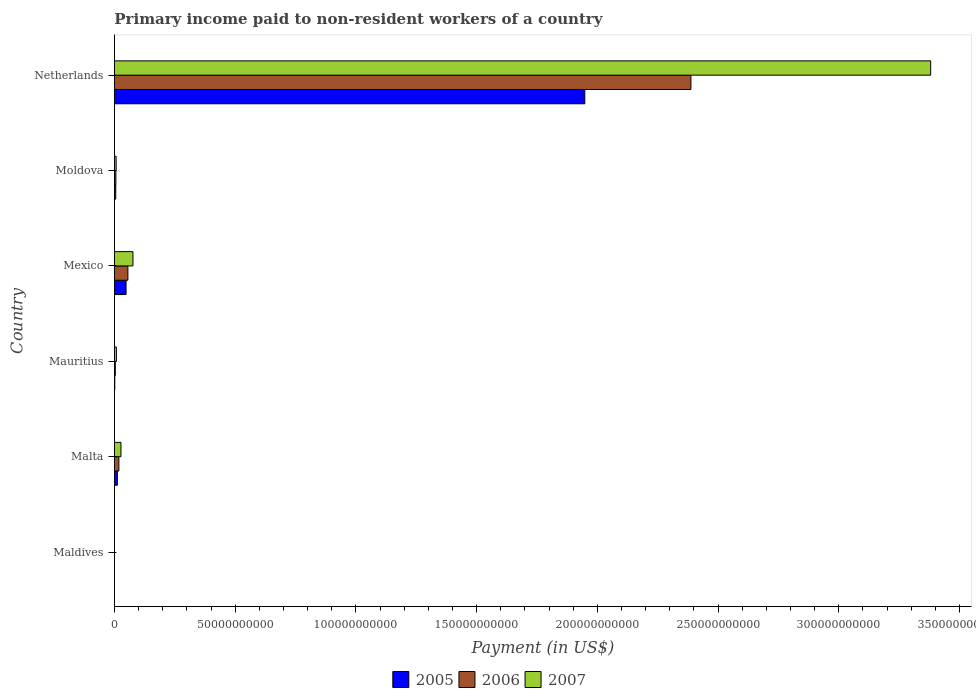How many different coloured bars are there?
Your answer should be compact. 3. How many groups of bars are there?
Keep it short and to the point. 6. Are the number of bars per tick equal to the number of legend labels?
Your answer should be very brief. Yes. Are the number of bars on each tick of the Y-axis equal?
Keep it short and to the point. Yes. What is the amount paid to workers in 2005 in Mauritius?
Provide a short and direct response. 1.43e+08. Across all countries, what is the maximum amount paid to workers in 2007?
Make the answer very short. 3.38e+11. Across all countries, what is the minimum amount paid to workers in 2005?
Make the answer very short. 1.09e+07. In which country was the amount paid to workers in 2005 minimum?
Provide a short and direct response. Maldives. What is the total amount paid to workers in 2006 in the graph?
Keep it short and to the point. 2.47e+11. What is the difference between the amount paid to workers in 2007 in Mauritius and that in Netherlands?
Your response must be concise. -3.37e+11. What is the difference between the amount paid to workers in 2006 in Moldova and the amount paid to workers in 2005 in Mauritius?
Offer a very short reply. 4.63e+08. What is the average amount paid to workers in 2007 per country?
Keep it short and to the point. 5.83e+1. What is the difference between the amount paid to workers in 2005 and amount paid to workers in 2006 in Mauritius?
Provide a succinct answer. -2.31e+08. In how many countries, is the amount paid to workers in 2005 greater than 80000000000 US$?
Make the answer very short. 1. What is the ratio of the amount paid to workers in 2007 in Moldova to that in Netherlands?
Make the answer very short. 0. Is the amount paid to workers in 2006 in Malta less than that in Mauritius?
Make the answer very short. No. Is the difference between the amount paid to workers in 2005 in Maldives and Netherlands greater than the difference between the amount paid to workers in 2006 in Maldives and Netherlands?
Make the answer very short. Yes. What is the difference between the highest and the second highest amount paid to workers in 2006?
Your answer should be very brief. 2.33e+11. What is the difference between the highest and the lowest amount paid to workers in 2006?
Provide a short and direct response. 2.39e+11. In how many countries, is the amount paid to workers in 2005 greater than the average amount paid to workers in 2005 taken over all countries?
Provide a succinct answer. 1. Is the sum of the amount paid to workers in 2007 in Malta and Mauritius greater than the maximum amount paid to workers in 2005 across all countries?
Your response must be concise. No. What does the 2nd bar from the bottom in Mauritius represents?
Provide a short and direct response. 2006. Is it the case that in every country, the sum of the amount paid to workers in 2006 and amount paid to workers in 2005 is greater than the amount paid to workers in 2007?
Ensure brevity in your answer.  No. Are all the bars in the graph horizontal?
Your response must be concise. Yes. Are the values on the major ticks of X-axis written in scientific E-notation?
Your answer should be very brief. No. Does the graph contain any zero values?
Give a very brief answer. No. Does the graph contain grids?
Provide a succinct answer. No. Where does the legend appear in the graph?
Keep it short and to the point. Bottom center. How are the legend labels stacked?
Ensure brevity in your answer.  Horizontal. What is the title of the graph?
Ensure brevity in your answer.  Primary income paid to non-resident workers of a country. What is the label or title of the X-axis?
Ensure brevity in your answer.  Payment (in US$). What is the Payment (in US$) of 2005 in Maldives?
Offer a very short reply. 1.09e+07. What is the Payment (in US$) in 2006 in Maldives?
Provide a succinct answer. 1.56e+07. What is the Payment (in US$) of 2007 in Maldives?
Your response must be concise. 2.67e+07. What is the Payment (in US$) of 2005 in Malta?
Offer a very short reply. 1.21e+09. What is the Payment (in US$) in 2006 in Malta?
Keep it short and to the point. 1.84e+09. What is the Payment (in US$) of 2007 in Malta?
Keep it short and to the point. 2.71e+09. What is the Payment (in US$) of 2005 in Mauritius?
Your answer should be very brief. 1.43e+08. What is the Payment (in US$) of 2006 in Mauritius?
Provide a short and direct response. 3.74e+08. What is the Payment (in US$) in 2007 in Mauritius?
Offer a terse response. 8.16e+08. What is the Payment (in US$) of 2005 in Mexico?
Give a very brief answer. 4.82e+09. What is the Payment (in US$) of 2006 in Mexico?
Offer a terse response. 5.58e+09. What is the Payment (in US$) of 2007 in Mexico?
Your answer should be compact. 7.66e+09. What is the Payment (in US$) of 2005 in Moldova?
Offer a terse response. 5.39e+08. What is the Payment (in US$) of 2006 in Moldova?
Offer a very short reply. 6.06e+08. What is the Payment (in US$) of 2007 in Moldova?
Offer a very short reply. 7.10e+08. What is the Payment (in US$) of 2005 in Netherlands?
Your answer should be very brief. 1.95e+11. What is the Payment (in US$) in 2006 in Netherlands?
Provide a succinct answer. 2.39e+11. What is the Payment (in US$) of 2007 in Netherlands?
Provide a short and direct response. 3.38e+11. Across all countries, what is the maximum Payment (in US$) in 2005?
Provide a short and direct response. 1.95e+11. Across all countries, what is the maximum Payment (in US$) in 2006?
Offer a very short reply. 2.39e+11. Across all countries, what is the maximum Payment (in US$) of 2007?
Keep it short and to the point. 3.38e+11. Across all countries, what is the minimum Payment (in US$) in 2005?
Offer a very short reply. 1.09e+07. Across all countries, what is the minimum Payment (in US$) of 2006?
Make the answer very short. 1.56e+07. Across all countries, what is the minimum Payment (in US$) of 2007?
Offer a terse response. 2.67e+07. What is the total Payment (in US$) in 2005 in the graph?
Provide a short and direct response. 2.02e+11. What is the total Payment (in US$) of 2006 in the graph?
Give a very brief answer. 2.47e+11. What is the total Payment (in US$) of 2007 in the graph?
Give a very brief answer. 3.50e+11. What is the difference between the Payment (in US$) of 2005 in Maldives and that in Malta?
Give a very brief answer. -1.20e+09. What is the difference between the Payment (in US$) in 2006 in Maldives and that in Malta?
Keep it short and to the point. -1.82e+09. What is the difference between the Payment (in US$) in 2007 in Maldives and that in Malta?
Ensure brevity in your answer.  -2.68e+09. What is the difference between the Payment (in US$) of 2005 in Maldives and that in Mauritius?
Ensure brevity in your answer.  -1.32e+08. What is the difference between the Payment (in US$) in 2006 in Maldives and that in Mauritius?
Make the answer very short. -3.58e+08. What is the difference between the Payment (in US$) of 2007 in Maldives and that in Mauritius?
Give a very brief answer. -7.90e+08. What is the difference between the Payment (in US$) of 2005 in Maldives and that in Mexico?
Provide a short and direct response. -4.81e+09. What is the difference between the Payment (in US$) in 2006 in Maldives and that in Mexico?
Your answer should be compact. -5.56e+09. What is the difference between the Payment (in US$) of 2007 in Maldives and that in Mexico?
Provide a succinct answer. -7.64e+09. What is the difference between the Payment (in US$) in 2005 in Maldives and that in Moldova?
Offer a terse response. -5.28e+08. What is the difference between the Payment (in US$) of 2006 in Maldives and that in Moldova?
Ensure brevity in your answer.  -5.90e+08. What is the difference between the Payment (in US$) in 2007 in Maldives and that in Moldova?
Ensure brevity in your answer.  -6.83e+08. What is the difference between the Payment (in US$) of 2005 in Maldives and that in Netherlands?
Give a very brief answer. -1.95e+11. What is the difference between the Payment (in US$) in 2006 in Maldives and that in Netherlands?
Your answer should be very brief. -2.39e+11. What is the difference between the Payment (in US$) in 2007 in Maldives and that in Netherlands?
Your answer should be very brief. -3.38e+11. What is the difference between the Payment (in US$) in 2005 in Malta and that in Mauritius?
Provide a succinct answer. 1.06e+09. What is the difference between the Payment (in US$) in 2006 in Malta and that in Mauritius?
Offer a very short reply. 1.47e+09. What is the difference between the Payment (in US$) in 2007 in Malta and that in Mauritius?
Your answer should be very brief. 1.89e+09. What is the difference between the Payment (in US$) in 2005 in Malta and that in Mexico?
Your response must be concise. -3.61e+09. What is the difference between the Payment (in US$) in 2006 in Malta and that in Mexico?
Make the answer very short. -3.74e+09. What is the difference between the Payment (in US$) of 2007 in Malta and that in Mexico?
Offer a very short reply. -4.95e+09. What is the difference between the Payment (in US$) of 2005 in Malta and that in Moldova?
Ensure brevity in your answer.  6.69e+08. What is the difference between the Payment (in US$) in 2006 in Malta and that in Moldova?
Make the answer very short. 1.23e+09. What is the difference between the Payment (in US$) in 2007 in Malta and that in Moldova?
Your answer should be very brief. 2.00e+09. What is the difference between the Payment (in US$) of 2005 in Malta and that in Netherlands?
Give a very brief answer. -1.94e+11. What is the difference between the Payment (in US$) of 2006 in Malta and that in Netherlands?
Your answer should be compact. -2.37e+11. What is the difference between the Payment (in US$) of 2007 in Malta and that in Netherlands?
Your response must be concise. -3.35e+11. What is the difference between the Payment (in US$) in 2005 in Mauritius and that in Mexico?
Provide a short and direct response. -4.68e+09. What is the difference between the Payment (in US$) in 2006 in Mauritius and that in Mexico?
Provide a succinct answer. -5.20e+09. What is the difference between the Payment (in US$) in 2007 in Mauritius and that in Mexico?
Make the answer very short. -6.85e+09. What is the difference between the Payment (in US$) of 2005 in Mauritius and that in Moldova?
Keep it short and to the point. -3.96e+08. What is the difference between the Payment (in US$) of 2006 in Mauritius and that in Moldova?
Offer a very short reply. -2.32e+08. What is the difference between the Payment (in US$) of 2007 in Mauritius and that in Moldova?
Offer a terse response. 1.06e+08. What is the difference between the Payment (in US$) of 2005 in Mauritius and that in Netherlands?
Offer a terse response. -1.95e+11. What is the difference between the Payment (in US$) in 2006 in Mauritius and that in Netherlands?
Offer a terse response. -2.38e+11. What is the difference between the Payment (in US$) in 2007 in Mauritius and that in Netherlands?
Give a very brief answer. -3.37e+11. What is the difference between the Payment (in US$) in 2005 in Mexico and that in Moldova?
Your answer should be compact. 4.28e+09. What is the difference between the Payment (in US$) in 2006 in Mexico and that in Moldova?
Make the answer very short. 4.97e+09. What is the difference between the Payment (in US$) of 2007 in Mexico and that in Moldova?
Make the answer very short. 6.95e+09. What is the difference between the Payment (in US$) in 2005 in Mexico and that in Netherlands?
Offer a terse response. -1.90e+11. What is the difference between the Payment (in US$) in 2006 in Mexico and that in Netherlands?
Offer a very short reply. -2.33e+11. What is the difference between the Payment (in US$) in 2007 in Mexico and that in Netherlands?
Your answer should be very brief. -3.30e+11. What is the difference between the Payment (in US$) of 2005 in Moldova and that in Netherlands?
Offer a terse response. -1.94e+11. What is the difference between the Payment (in US$) in 2006 in Moldova and that in Netherlands?
Keep it short and to the point. -2.38e+11. What is the difference between the Payment (in US$) in 2007 in Moldova and that in Netherlands?
Your response must be concise. -3.37e+11. What is the difference between the Payment (in US$) of 2005 in Maldives and the Payment (in US$) of 2006 in Malta?
Offer a terse response. -1.83e+09. What is the difference between the Payment (in US$) in 2005 in Maldives and the Payment (in US$) in 2007 in Malta?
Make the answer very short. -2.70e+09. What is the difference between the Payment (in US$) in 2006 in Maldives and the Payment (in US$) in 2007 in Malta?
Give a very brief answer. -2.70e+09. What is the difference between the Payment (in US$) of 2005 in Maldives and the Payment (in US$) of 2006 in Mauritius?
Provide a succinct answer. -3.63e+08. What is the difference between the Payment (in US$) of 2005 in Maldives and the Payment (in US$) of 2007 in Mauritius?
Provide a short and direct response. -8.05e+08. What is the difference between the Payment (in US$) in 2006 in Maldives and the Payment (in US$) in 2007 in Mauritius?
Make the answer very short. -8.01e+08. What is the difference between the Payment (in US$) of 2005 in Maldives and the Payment (in US$) of 2006 in Mexico?
Provide a short and direct response. -5.57e+09. What is the difference between the Payment (in US$) in 2005 in Maldives and the Payment (in US$) in 2007 in Mexico?
Provide a short and direct response. -7.65e+09. What is the difference between the Payment (in US$) in 2006 in Maldives and the Payment (in US$) in 2007 in Mexico?
Your answer should be very brief. -7.65e+09. What is the difference between the Payment (in US$) of 2005 in Maldives and the Payment (in US$) of 2006 in Moldova?
Your answer should be compact. -5.95e+08. What is the difference between the Payment (in US$) in 2005 in Maldives and the Payment (in US$) in 2007 in Moldova?
Make the answer very short. -6.99e+08. What is the difference between the Payment (in US$) of 2006 in Maldives and the Payment (in US$) of 2007 in Moldova?
Provide a succinct answer. -6.95e+08. What is the difference between the Payment (in US$) in 2005 in Maldives and the Payment (in US$) in 2006 in Netherlands?
Give a very brief answer. -2.39e+11. What is the difference between the Payment (in US$) in 2005 in Maldives and the Payment (in US$) in 2007 in Netherlands?
Provide a succinct answer. -3.38e+11. What is the difference between the Payment (in US$) in 2006 in Maldives and the Payment (in US$) in 2007 in Netherlands?
Provide a succinct answer. -3.38e+11. What is the difference between the Payment (in US$) of 2005 in Malta and the Payment (in US$) of 2006 in Mauritius?
Offer a terse response. 8.34e+08. What is the difference between the Payment (in US$) of 2005 in Malta and the Payment (in US$) of 2007 in Mauritius?
Provide a short and direct response. 3.91e+08. What is the difference between the Payment (in US$) in 2006 in Malta and the Payment (in US$) in 2007 in Mauritius?
Your answer should be very brief. 1.02e+09. What is the difference between the Payment (in US$) of 2005 in Malta and the Payment (in US$) of 2006 in Mexico?
Your answer should be compact. -4.37e+09. What is the difference between the Payment (in US$) in 2005 in Malta and the Payment (in US$) in 2007 in Mexico?
Offer a terse response. -6.46e+09. What is the difference between the Payment (in US$) in 2006 in Malta and the Payment (in US$) in 2007 in Mexico?
Offer a very short reply. -5.82e+09. What is the difference between the Payment (in US$) of 2005 in Malta and the Payment (in US$) of 2006 in Moldova?
Make the answer very short. 6.02e+08. What is the difference between the Payment (in US$) of 2005 in Malta and the Payment (in US$) of 2007 in Moldova?
Keep it short and to the point. 4.98e+08. What is the difference between the Payment (in US$) in 2006 in Malta and the Payment (in US$) in 2007 in Moldova?
Provide a short and direct response. 1.13e+09. What is the difference between the Payment (in US$) in 2005 in Malta and the Payment (in US$) in 2006 in Netherlands?
Give a very brief answer. -2.38e+11. What is the difference between the Payment (in US$) in 2005 in Malta and the Payment (in US$) in 2007 in Netherlands?
Keep it short and to the point. -3.37e+11. What is the difference between the Payment (in US$) of 2006 in Malta and the Payment (in US$) of 2007 in Netherlands?
Your answer should be very brief. -3.36e+11. What is the difference between the Payment (in US$) of 2005 in Mauritius and the Payment (in US$) of 2006 in Mexico?
Offer a terse response. -5.44e+09. What is the difference between the Payment (in US$) in 2005 in Mauritius and the Payment (in US$) in 2007 in Mexico?
Give a very brief answer. -7.52e+09. What is the difference between the Payment (in US$) in 2006 in Mauritius and the Payment (in US$) in 2007 in Mexico?
Your response must be concise. -7.29e+09. What is the difference between the Payment (in US$) in 2005 in Mauritius and the Payment (in US$) in 2006 in Moldova?
Your answer should be compact. -4.63e+08. What is the difference between the Payment (in US$) of 2005 in Mauritius and the Payment (in US$) of 2007 in Moldova?
Provide a succinct answer. -5.67e+08. What is the difference between the Payment (in US$) of 2006 in Mauritius and the Payment (in US$) of 2007 in Moldova?
Offer a very short reply. -3.36e+08. What is the difference between the Payment (in US$) of 2005 in Mauritius and the Payment (in US$) of 2006 in Netherlands?
Your answer should be very brief. -2.39e+11. What is the difference between the Payment (in US$) of 2005 in Mauritius and the Payment (in US$) of 2007 in Netherlands?
Your response must be concise. -3.38e+11. What is the difference between the Payment (in US$) in 2006 in Mauritius and the Payment (in US$) in 2007 in Netherlands?
Make the answer very short. -3.38e+11. What is the difference between the Payment (in US$) of 2005 in Mexico and the Payment (in US$) of 2006 in Moldova?
Make the answer very short. 4.21e+09. What is the difference between the Payment (in US$) of 2005 in Mexico and the Payment (in US$) of 2007 in Moldova?
Your answer should be compact. 4.11e+09. What is the difference between the Payment (in US$) in 2006 in Mexico and the Payment (in US$) in 2007 in Moldova?
Ensure brevity in your answer.  4.87e+09. What is the difference between the Payment (in US$) of 2005 in Mexico and the Payment (in US$) of 2006 in Netherlands?
Provide a succinct answer. -2.34e+11. What is the difference between the Payment (in US$) in 2005 in Mexico and the Payment (in US$) in 2007 in Netherlands?
Provide a short and direct response. -3.33e+11. What is the difference between the Payment (in US$) in 2006 in Mexico and the Payment (in US$) in 2007 in Netherlands?
Make the answer very short. -3.32e+11. What is the difference between the Payment (in US$) in 2005 in Moldova and the Payment (in US$) in 2006 in Netherlands?
Ensure brevity in your answer.  -2.38e+11. What is the difference between the Payment (in US$) of 2005 in Moldova and the Payment (in US$) of 2007 in Netherlands?
Your response must be concise. -3.37e+11. What is the difference between the Payment (in US$) in 2006 in Moldova and the Payment (in US$) in 2007 in Netherlands?
Provide a succinct answer. -3.37e+11. What is the average Payment (in US$) of 2005 per country?
Your response must be concise. 3.36e+1. What is the average Payment (in US$) of 2006 per country?
Ensure brevity in your answer.  4.12e+1. What is the average Payment (in US$) of 2007 per country?
Offer a very short reply. 5.83e+1. What is the difference between the Payment (in US$) in 2005 and Payment (in US$) in 2006 in Maldives?
Keep it short and to the point. -4.70e+06. What is the difference between the Payment (in US$) in 2005 and Payment (in US$) in 2007 in Maldives?
Keep it short and to the point. -1.58e+07. What is the difference between the Payment (in US$) in 2006 and Payment (in US$) in 2007 in Maldives?
Your response must be concise. -1.11e+07. What is the difference between the Payment (in US$) of 2005 and Payment (in US$) of 2006 in Malta?
Provide a short and direct response. -6.32e+08. What is the difference between the Payment (in US$) of 2005 and Payment (in US$) of 2007 in Malta?
Give a very brief answer. -1.50e+09. What is the difference between the Payment (in US$) in 2006 and Payment (in US$) in 2007 in Malta?
Keep it short and to the point. -8.71e+08. What is the difference between the Payment (in US$) of 2005 and Payment (in US$) of 2006 in Mauritius?
Your answer should be compact. -2.31e+08. What is the difference between the Payment (in US$) of 2005 and Payment (in US$) of 2007 in Mauritius?
Make the answer very short. -6.74e+08. What is the difference between the Payment (in US$) in 2006 and Payment (in US$) in 2007 in Mauritius?
Make the answer very short. -4.42e+08. What is the difference between the Payment (in US$) in 2005 and Payment (in US$) in 2006 in Mexico?
Make the answer very short. -7.60e+08. What is the difference between the Payment (in US$) in 2005 and Payment (in US$) in 2007 in Mexico?
Offer a very short reply. -2.85e+09. What is the difference between the Payment (in US$) of 2006 and Payment (in US$) of 2007 in Mexico?
Offer a terse response. -2.09e+09. What is the difference between the Payment (in US$) in 2005 and Payment (in US$) in 2006 in Moldova?
Your answer should be compact. -6.66e+07. What is the difference between the Payment (in US$) in 2005 and Payment (in US$) in 2007 in Moldova?
Your answer should be compact. -1.71e+08. What is the difference between the Payment (in US$) of 2006 and Payment (in US$) of 2007 in Moldova?
Your answer should be very brief. -1.04e+08. What is the difference between the Payment (in US$) in 2005 and Payment (in US$) in 2006 in Netherlands?
Keep it short and to the point. -4.40e+1. What is the difference between the Payment (in US$) of 2005 and Payment (in US$) of 2007 in Netherlands?
Your answer should be compact. -1.43e+11. What is the difference between the Payment (in US$) of 2006 and Payment (in US$) of 2007 in Netherlands?
Make the answer very short. -9.93e+1. What is the ratio of the Payment (in US$) of 2005 in Maldives to that in Malta?
Make the answer very short. 0.01. What is the ratio of the Payment (in US$) of 2006 in Maldives to that in Malta?
Your answer should be very brief. 0.01. What is the ratio of the Payment (in US$) in 2007 in Maldives to that in Malta?
Give a very brief answer. 0.01. What is the ratio of the Payment (in US$) in 2005 in Maldives to that in Mauritius?
Provide a short and direct response. 0.08. What is the ratio of the Payment (in US$) in 2006 in Maldives to that in Mauritius?
Give a very brief answer. 0.04. What is the ratio of the Payment (in US$) in 2007 in Maldives to that in Mauritius?
Your response must be concise. 0.03. What is the ratio of the Payment (in US$) of 2005 in Maldives to that in Mexico?
Your answer should be very brief. 0. What is the ratio of the Payment (in US$) of 2006 in Maldives to that in Mexico?
Give a very brief answer. 0. What is the ratio of the Payment (in US$) in 2007 in Maldives to that in Mexico?
Provide a succinct answer. 0. What is the ratio of the Payment (in US$) in 2005 in Maldives to that in Moldova?
Your answer should be compact. 0.02. What is the ratio of the Payment (in US$) of 2006 in Maldives to that in Moldova?
Give a very brief answer. 0.03. What is the ratio of the Payment (in US$) in 2007 in Maldives to that in Moldova?
Offer a very short reply. 0.04. What is the ratio of the Payment (in US$) in 2005 in Maldives to that in Netherlands?
Your response must be concise. 0. What is the ratio of the Payment (in US$) in 2006 in Maldives to that in Netherlands?
Keep it short and to the point. 0. What is the ratio of the Payment (in US$) of 2005 in Malta to that in Mauritius?
Offer a terse response. 8.45. What is the ratio of the Payment (in US$) in 2006 in Malta to that in Mauritius?
Offer a terse response. 4.92. What is the ratio of the Payment (in US$) of 2007 in Malta to that in Mauritius?
Provide a short and direct response. 3.32. What is the ratio of the Payment (in US$) in 2005 in Malta to that in Mexico?
Keep it short and to the point. 0.25. What is the ratio of the Payment (in US$) of 2006 in Malta to that in Mexico?
Offer a terse response. 0.33. What is the ratio of the Payment (in US$) in 2007 in Malta to that in Mexico?
Your answer should be very brief. 0.35. What is the ratio of the Payment (in US$) in 2005 in Malta to that in Moldova?
Give a very brief answer. 2.24. What is the ratio of the Payment (in US$) in 2006 in Malta to that in Moldova?
Offer a very short reply. 3.04. What is the ratio of the Payment (in US$) in 2007 in Malta to that in Moldova?
Your answer should be compact. 3.82. What is the ratio of the Payment (in US$) in 2005 in Malta to that in Netherlands?
Keep it short and to the point. 0.01. What is the ratio of the Payment (in US$) of 2006 in Malta to that in Netherlands?
Give a very brief answer. 0.01. What is the ratio of the Payment (in US$) in 2007 in Malta to that in Netherlands?
Your answer should be compact. 0.01. What is the ratio of the Payment (in US$) of 2005 in Mauritius to that in Mexico?
Offer a very short reply. 0.03. What is the ratio of the Payment (in US$) of 2006 in Mauritius to that in Mexico?
Offer a very short reply. 0.07. What is the ratio of the Payment (in US$) of 2007 in Mauritius to that in Mexico?
Your answer should be compact. 0.11. What is the ratio of the Payment (in US$) of 2005 in Mauritius to that in Moldova?
Make the answer very short. 0.26. What is the ratio of the Payment (in US$) in 2006 in Mauritius to that in Moldova?
Your answer should be compact. 0.62. What is the ratio of the Payment (in US$) in 2007 in Mauritius to that in Moldova?
Make the answer very short. 1.15. What is the ratio of the Payment (in US$) in 2005 in Mauritius to that in Netherlands?
Offer a very short reply. 0. What is the ratio of the Payment (in US$) of 2006 in Mauritius to that in Netherlands?
Your answer should be compact. 0. What is the ratio of the Payment (in US$) in 2007 in Mauritius to that in Netherlands?
Ensure brevity in your answer.  0. What is the ratio of the Payment (in US$) of 2005 in Mexico to that in Moldova?
Offer a terse response. 8.94. What is the ratio of the Payment (in US$) of 2006 in Mexico to that in Moldova?
Give a very brief answer. 9.21. What is the ratio of the Payment (in US$) in 2007 in Mexico to that in Moldova?
Make the answer very short. 10.79. What is the ratio of the Payment (in US$) in 2005 in Mexico to that in Netherlands?
Give a very brief answer. 0.02. What is the ratio of the Payment (in US$) of 2006 in Mexico to that in Netherlands?
Ensure brevity in your answer.  0.02. What is the ratio of the Payment (in US$) of 2007 in Mexico to that in Netherlands?
Provide a succinct answer. 0.02. What is the ratio of the Payment (in US$) of 2005 in Moldova to that in Netherlands?
Keep it short and to the point. 0. What is the ratio of the Payment (in US$) in 2006 in Moldova to that in Netherlands?
Give a very brief answer. 0. What is the ratio of the Payment (in US$) of 2007 in Moldova to that in Netherlands?
Your answer should be compact. 0. What is the difference between the highest and the second highest Payment (in US$) of 2005?
Make the answer very short. 1.90e+11. What is the difference between the highest and the second highest Payment (in US$) in 2006?
Provide a succinct answer. 2.33e+11. What is the difference between the highest and the second highest Payment (in US$) in 2007?
Your answer should be very brief. 3.30e+11. What is the difference between the highest and the lowest Payment (in US$) of 2005?
Your answer should be very brief. 1.95e+11. What is the difference between the highest and the lowest Payment (in US$) in 2006?
Ensure brevity in your answer.  2.39e+11. What is the difference between the highest and the lowest Payment (in US$) in 2007?
Ensure brevity in your answer.  3.38e+11. 